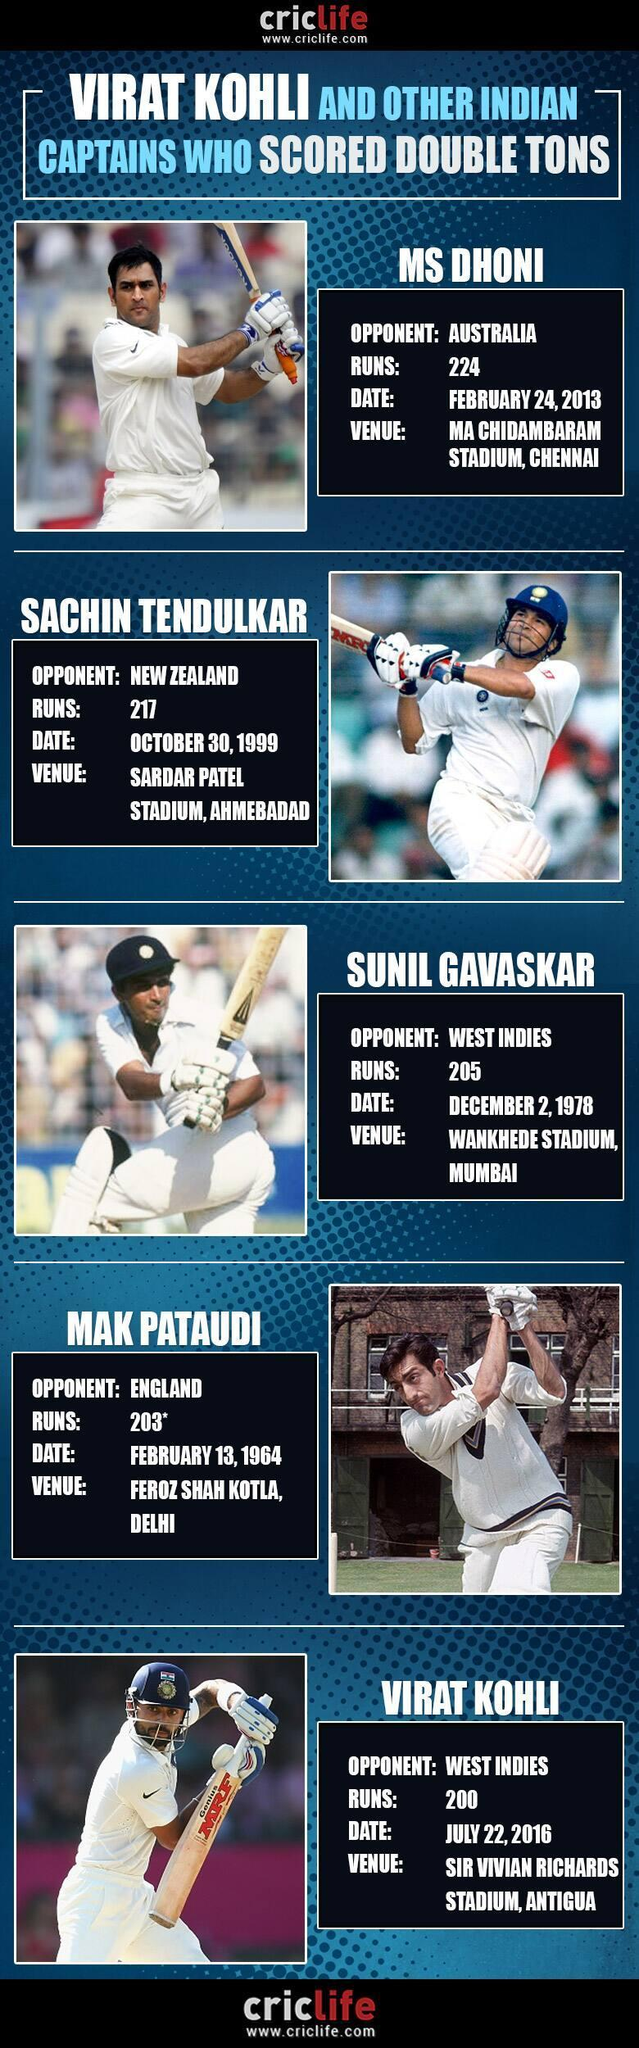How many images of cricketers mentioned in this infographic?
Answer the question with a short phrase. 5 